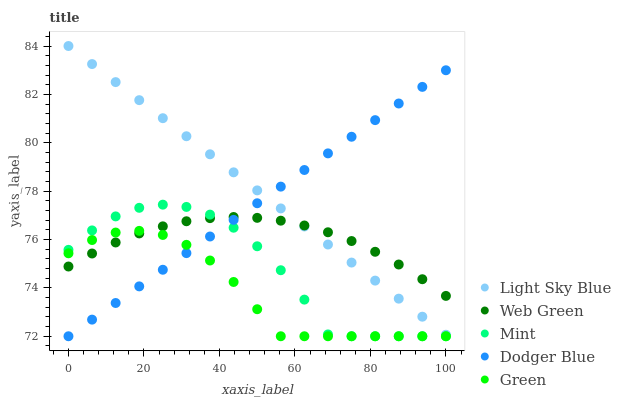Does Green have the minimum area under the curve?
Answer yes or no. Yes. Does Light Sky Blue have the maximum area under the curve?
Answer yes or no. Yes. Does Mint have the minimum area under the curve?
Answer yes or no. No. Does Mint have the maximum area under the curve?
Answer yes or no. No. Is Dodger Blue the smoothest?
Answer yes or no. Yes. Is Mint the roughest?
Answer yes or no. Yes. Is Light Sky Blue the smoothest?
Answer yes or no. No. Is Light Sky Blue the roughest?
Answer yes or no. No. Does Dodger Blue have the lowest value?
Answer yes or no. Yes. Does Light Sky Blue have the lowest value?
Answer yes or no. No. Does Light Sky Blue have the highest value?
Answer yes or no. Yes. Does Mint have the highest value?
Answer yes or no. No. Is Green less than Light Sky Blue?
Answer yes or no. Yes. Is Light Sky Blue greater than Green?
Answer yes or no. Yes. Does Web Green intersect Dodger Blue?
Answer yes or no. Yes. Is Web Green less than Dodger Blue?
Answer yes or no. No. Is Web Green greater than Dodger Blue?
Answer yes or no. No. Does Green intersect Light Sky Blue?
Answer yes or no. No. 